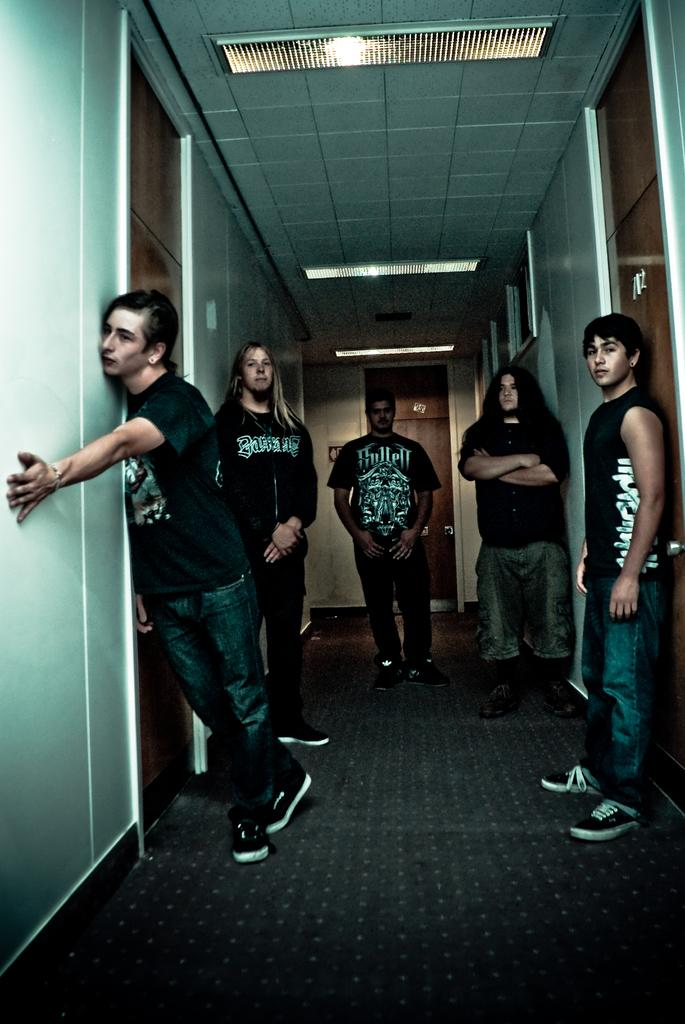What can be observed about the people in the image? There are people standing in the image, and they are wearing T-shirts. Can you describe the clothing of one of the men in the image? One man is wearing a sleeveless T-shirt. What architectural features can be seen in the image? There are doors visible in the image. What type of lighting is present in the image? There are lights on the ceiling. What type of flooring is present in the image? There is a carpet on the floor. What type of vegetable is being used as a decoration on the sleeveless T-shirt? There is no vegetable present on the sleeveless T-shirt in the image. 